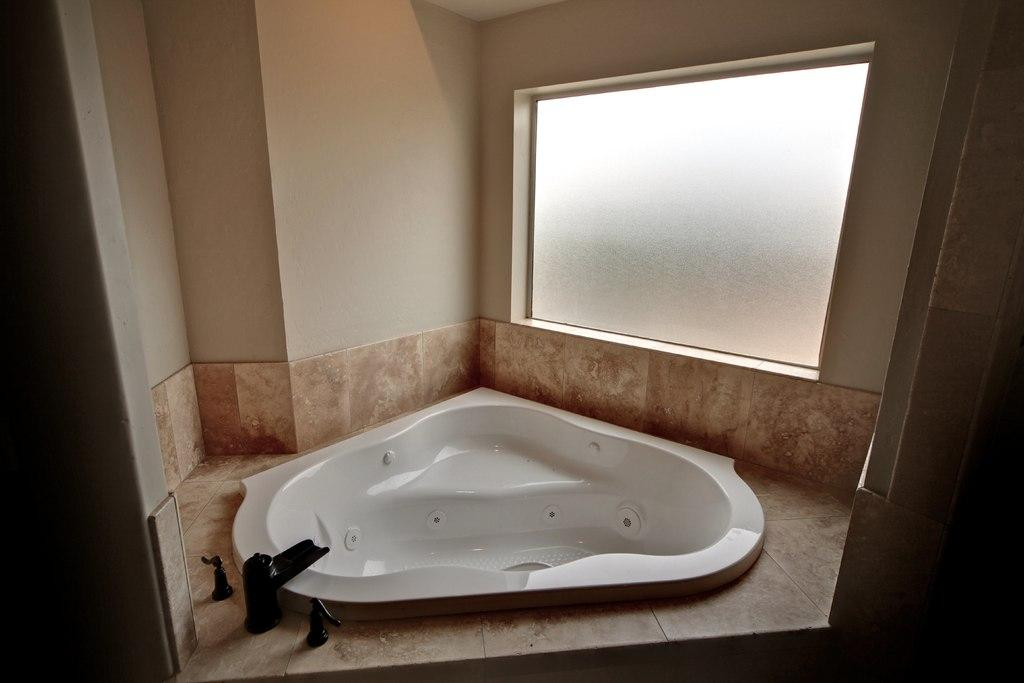What type of view is shown in the image? The image is an inside view. What can be seen at the bottom of the image? There is a bathtub at the bottom of the image. What is visible in the background of the image? There is a window in the background of the image. Where is the window located in the image? The window is on a wall. What is located beside the bathtub? There is a tap beside the bathtub. What song is being sung by the bathtub in the image? There is no indication in the image that the bathtub is singing a song, as it is an inanimate object. 